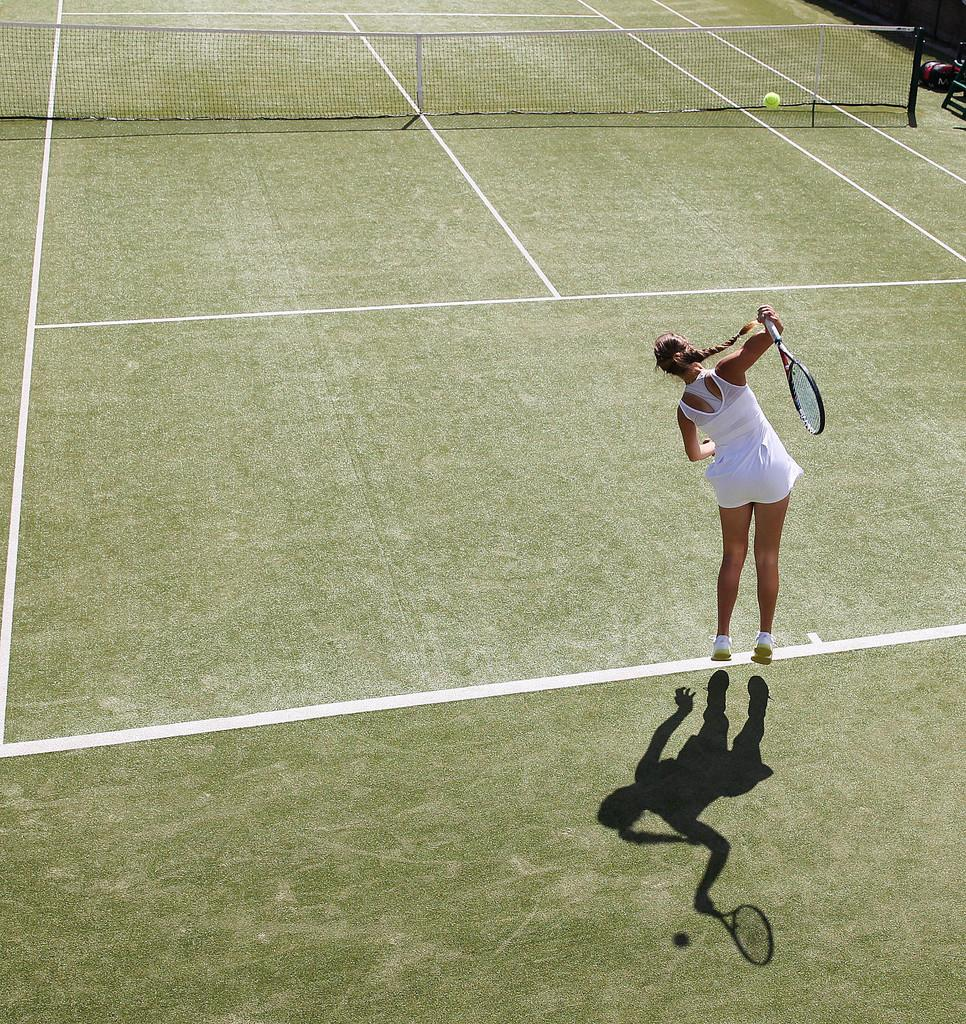What type of sports facility is shown in the image? The image depicts a tennis court. What is a key feature of a tennis court? There is a net on the tennis court. Who is present in the image? A tennis player is present in the image. What is the tennis player holding? The tennis player is holding a tennis bat. What action is the tennis player attempting to perform? The tennis player is attempting to hit a tennis ball. What type of canvas is visible in the image? There is no canvas present in the image; it depicts a tennis court with a tennis player. What is the name of the downtown street where the tennis court is located? The image does not provide information about the location of the tennis court, so it cannot be determined if it is in a downtown area. 